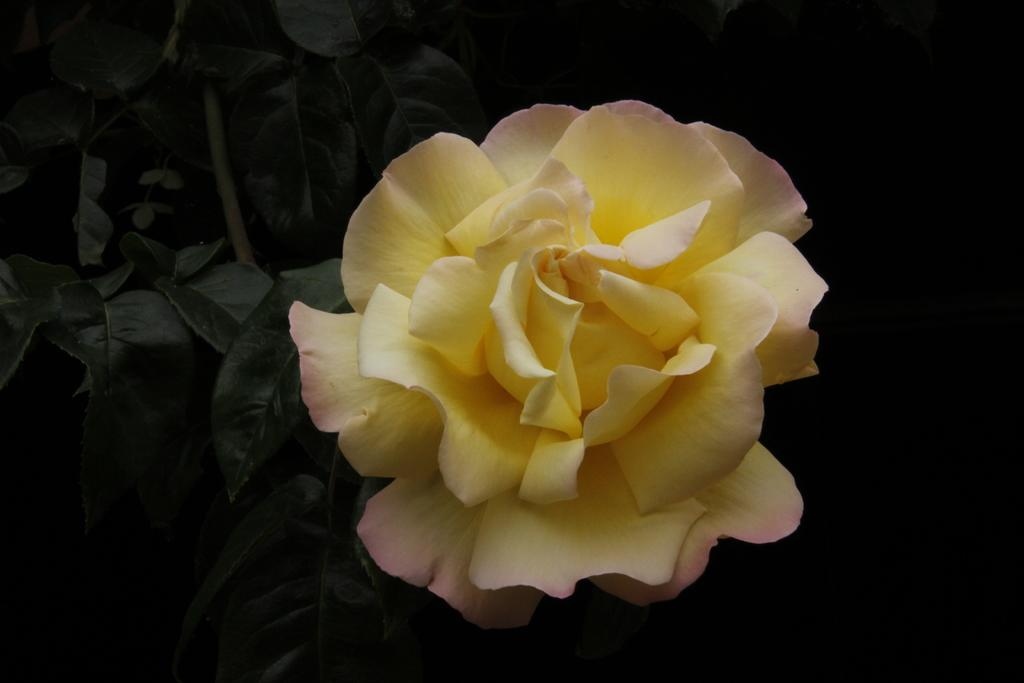What type of plant life is visible in the image? There are green leaves in the image. What type of flower can be seen in the image? There is a yellow rose flower in the image. What part of the image is dark? The right side portion of the image is completely dark. What type of test is being conducted in the image? There is no indication of a test being conducted in the image. Can you see a kettle in the image? There is no kettle present in the image. 